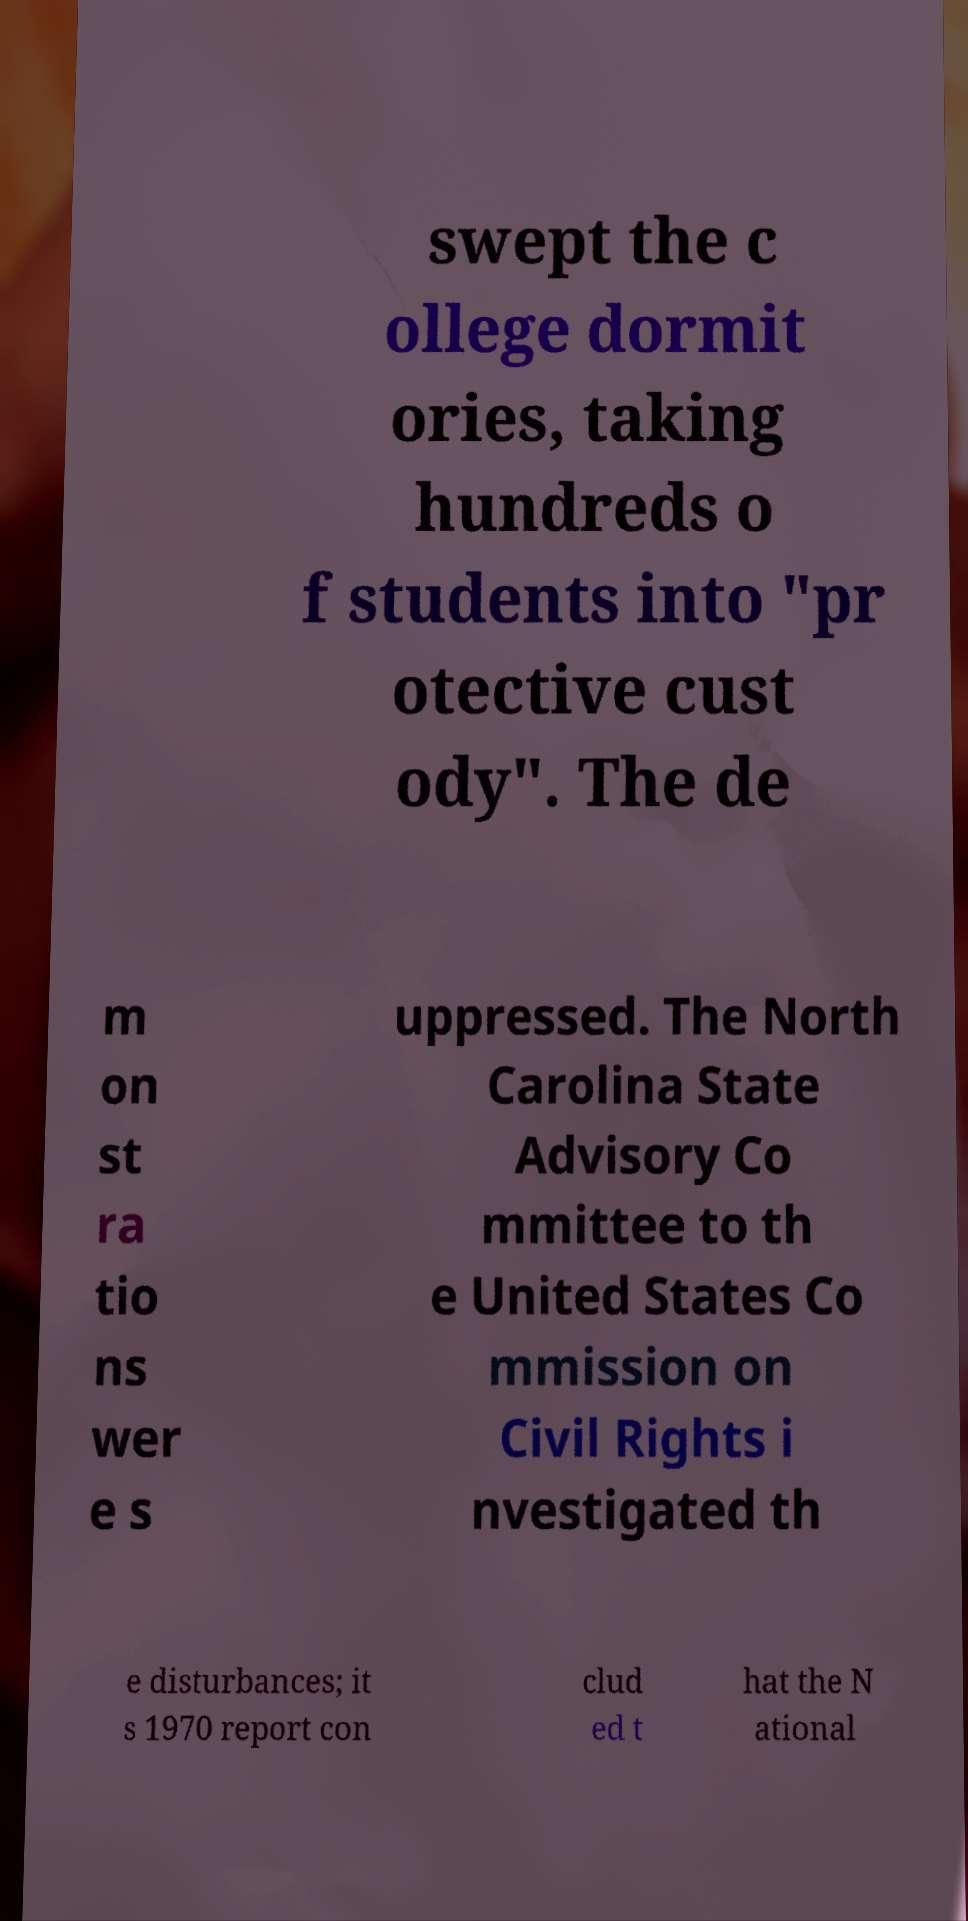Can you accurately transcribe the text from the provided image for me? swept the c ollege dormit ories, taking hundreds o f students into "pr otective cust ody". The de m on st ra tio ns wer e s uppressed. The North Carolina State Advisory Co mmittee to th e United States Co mmission on Civil Rights i nvestigated th e disturbances; it s 1970 report con clud ed t hat the N ational 